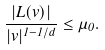Convert formula to latex. <formula><loc_0><loc_0><loc_500><loc_500>\frac { | L ( v ) | } { | v | ^ { 1 - 1 / d } } \leq \mu _ { 0 } .</formula> 